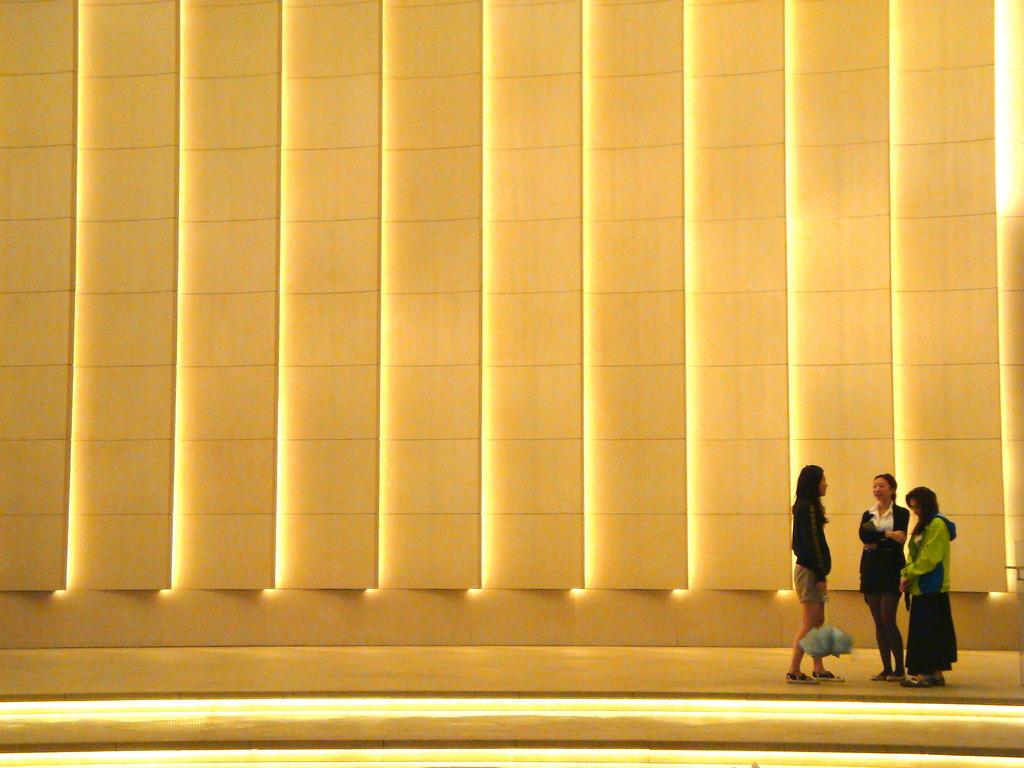How many women are present in the image? There are three women in the image. What are the women wearing? Two of the women are wearing black dresses. What color is the wall in the background of the image? There is a yellow wall in the background of the image. How many apples are on the table in the image? There is no table or apples present in the image. Can you see a bee flying around the women in the image? There is no bee visible in the image. 